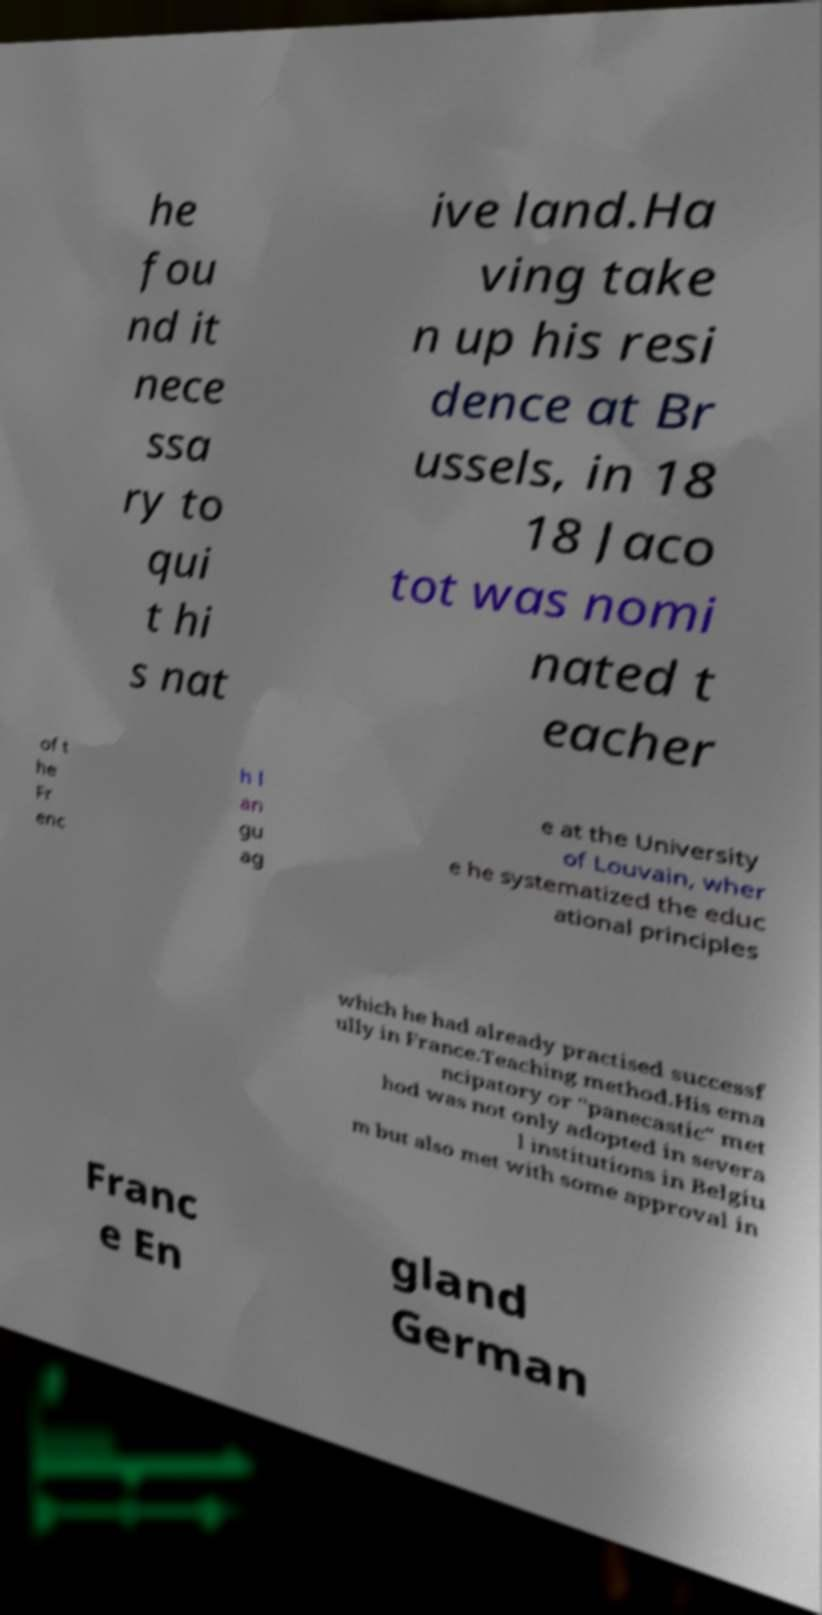What messages or text are displayed in this image? I need them in a readable, typed format. he fou nd it nece ssa ry to qui t hi s nat ive land.Ha ving take n up his resi dence at Br ussels, in 18 18 Jaco tot was nomi nated t eacher of t he Fr enc h l an gu ag e at the University of Louvain, wher e he systematized the educ ational principles which he had already practised successf ully in France.Teaching method.His ema ncipatory or "panecastic" met hod was not only adopted in severa l institutions in Belgiu m but also met with some approval in Franc e En gland German 